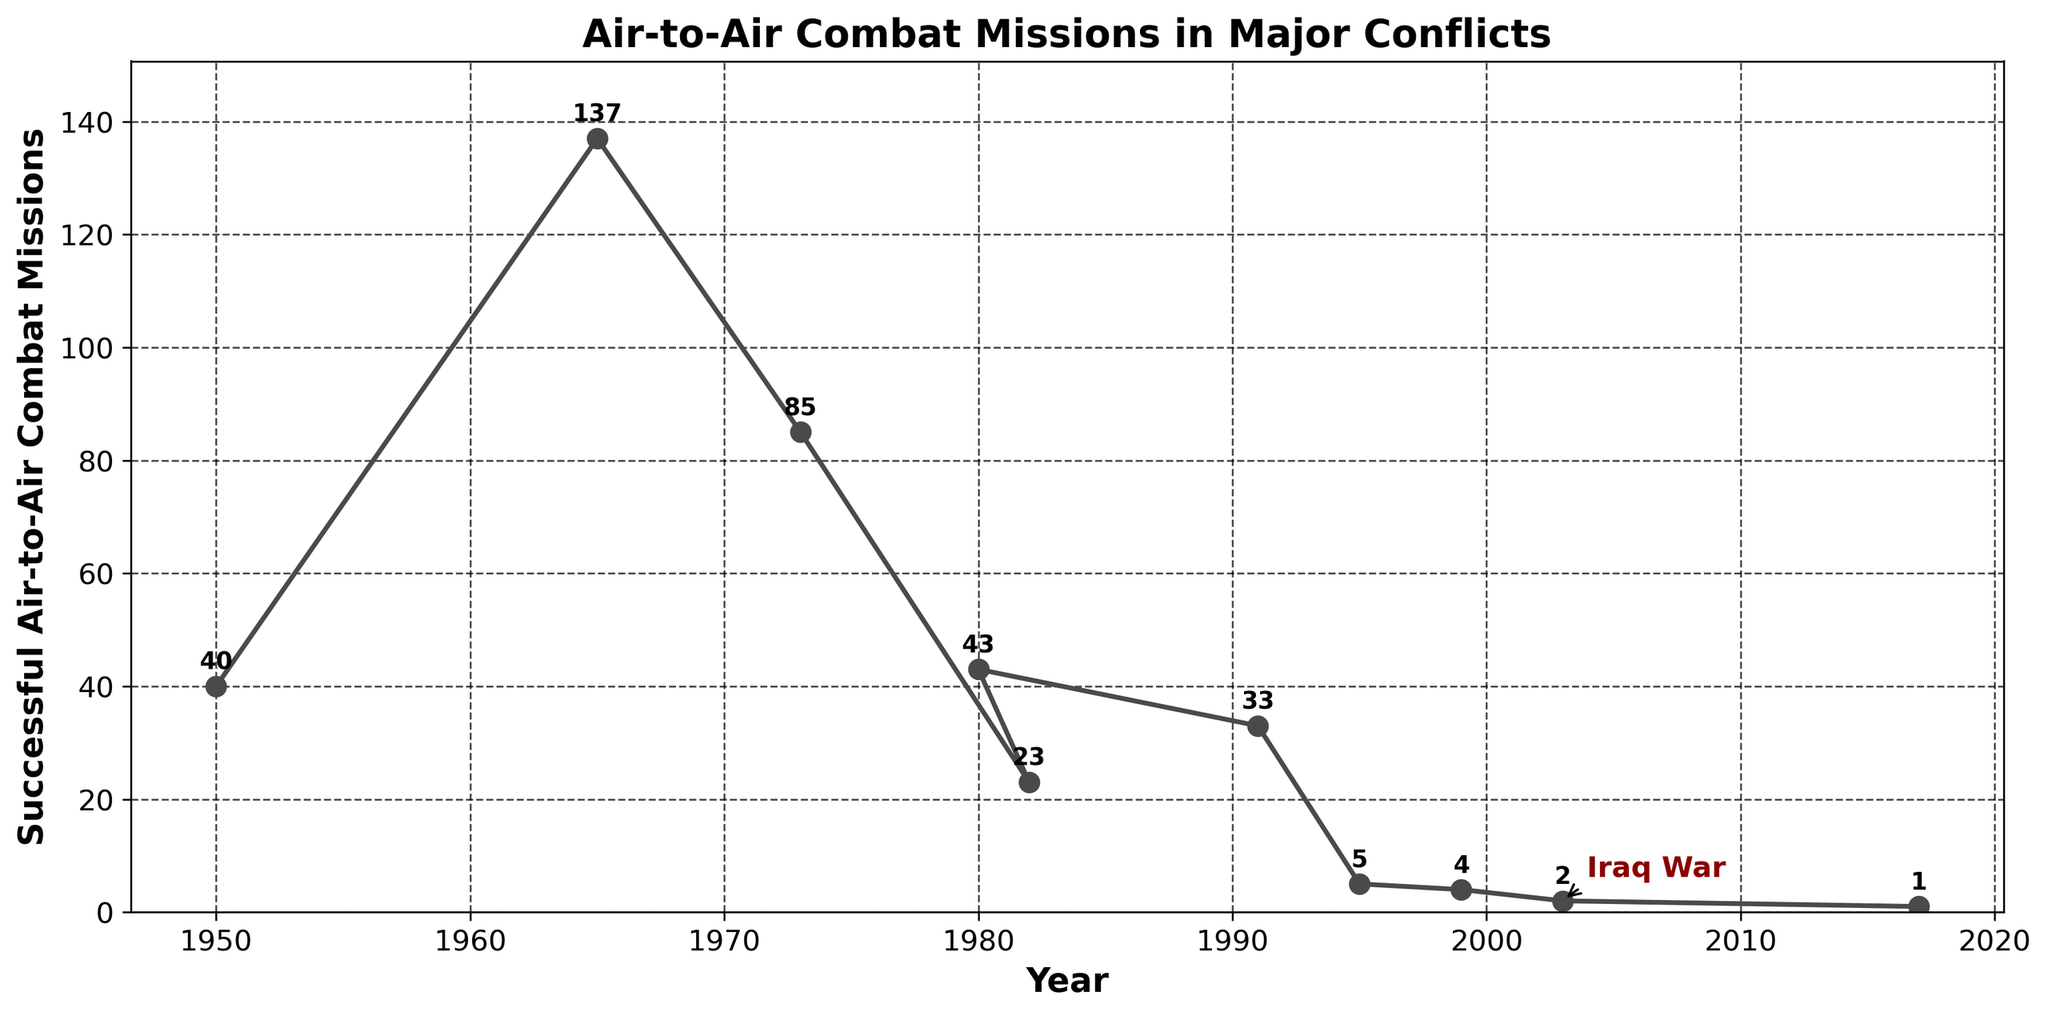How many successful air-to-air combat missions took place during the Iraq War? To find this, identify the year corresponding to the Iraq War (2003) and read the number of missions directly from the plot.
Answer: 2 Which conflict had the highest number of successful air-to-air combat missions and how many were there? Look for the data point with the highest value along the y-axis. The Vietnam War, around 1965, has the highest number with 137 missions.
Answer: Vietnam War, 137 What is the difference in the number of successful air-to-air combat missions between the Vietnam War and the Iraq War? Identify the number of missions for both conflicts (Vietnam War: 137, Iraq War: 2) and subtract the Iraq War's missions from the Vietnam War's. 137 - 2 = 135
Answer: 135 During which conflict did the number of successful air-to-air combat missions first drop below 10 after the Vietnam War? Starting from the Vietnam War, move along the timeline and look for the first conflict with missions fewer than 10. The Bosnia and Herzegovina conflict in 1995 shows only 5 missions.
Answer: Bosnia and Herzegovina What is the average number of successful air-to-air combat missions for all conflicts shown in the figure? Sum the numbers of missions for all conflicts and divide by the number of conflicts. (40 + 137 + 85 + 23 + 43 + 33 + 5 + 4 + 2 + 1) / 10 = 37.3
Answer: 37.3 Compare the number of successful air-to-air combat missions in the Gulf War to the Arab-Israeli War. Which had more and by how much? Identify the missions for both conflicts (Gulf War: 33, Arab-Israeli War: 85) and subtract the Gulf War's missions from the Arab-Israeli War's. 85 - 33 = 52
Answer: Arab-Israeli War, 52 Which conflicts had fewer successful air-to-air combat missions than the Iraq War? Identify the number of missions in the Iraq War (2) and note any conflict with fewer missions. The only conflict with fewer missions is the Syrian Civil War in 2017 with 1 mission.
Answer: Syrian Civil War What is the combined total of successful air-to-air combat missions for the Korean War and the Falklands War? Sum the missions for the Korean War (40) and the Falklands War (23). 40 + 23 = 63
Answer: 63 During which year did successful air-to-air combat missions reach their lowest point, according to the figure? Look for the lowest value on the y-axis and identify the corresponding year; it's the Syrian Civil War in 2017 with 1 mission.
Answer: 2017 